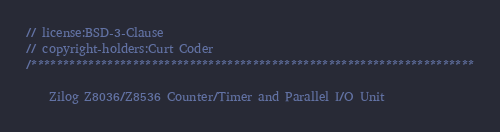<code> <loc_0><loc_0><loc_500><loc_500><_C++_>// license:BSD-3-Clause
// copyright-holders:Curt Coder
/**********************************************************************

    Zilog Z8036/Z8536 Counter/Timer and Parallel I/O Unit
</code> 